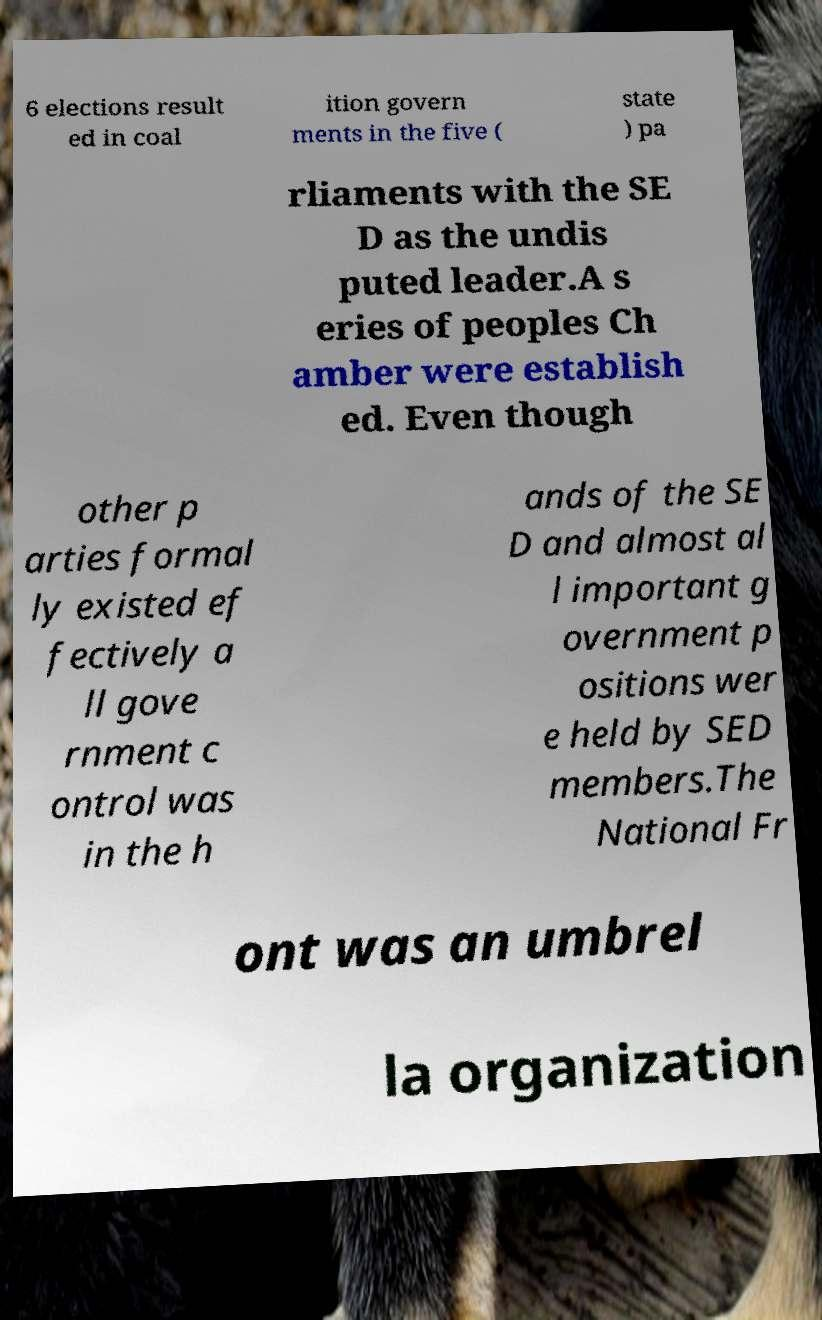Please identify and transcribe the text found in this image. 6 elections result ed in coal ition govern ments in the five ( state ) pa rliaments with the SE D as the undis puted leader.A s eries of peoples Ch amber were establish ed. Even though other p arties formal ly existed ef fectively a ll gove rnment c ontrol was in the h ands of the SE D and almost al l important g overnment p ositions wer e held by SED members.The National Fr ont was an umbrel la organization 